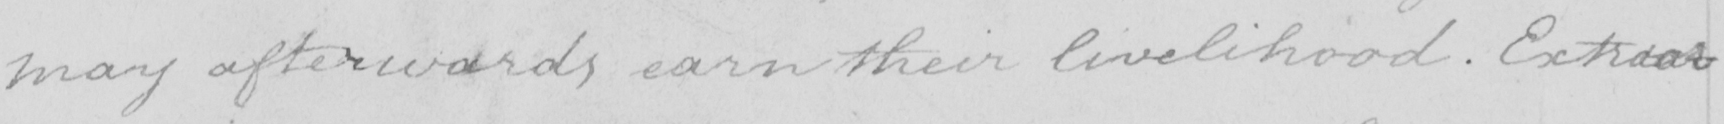Please provide the text content of this handwritten line. may afterwards earn their livelihood . Extraor- 